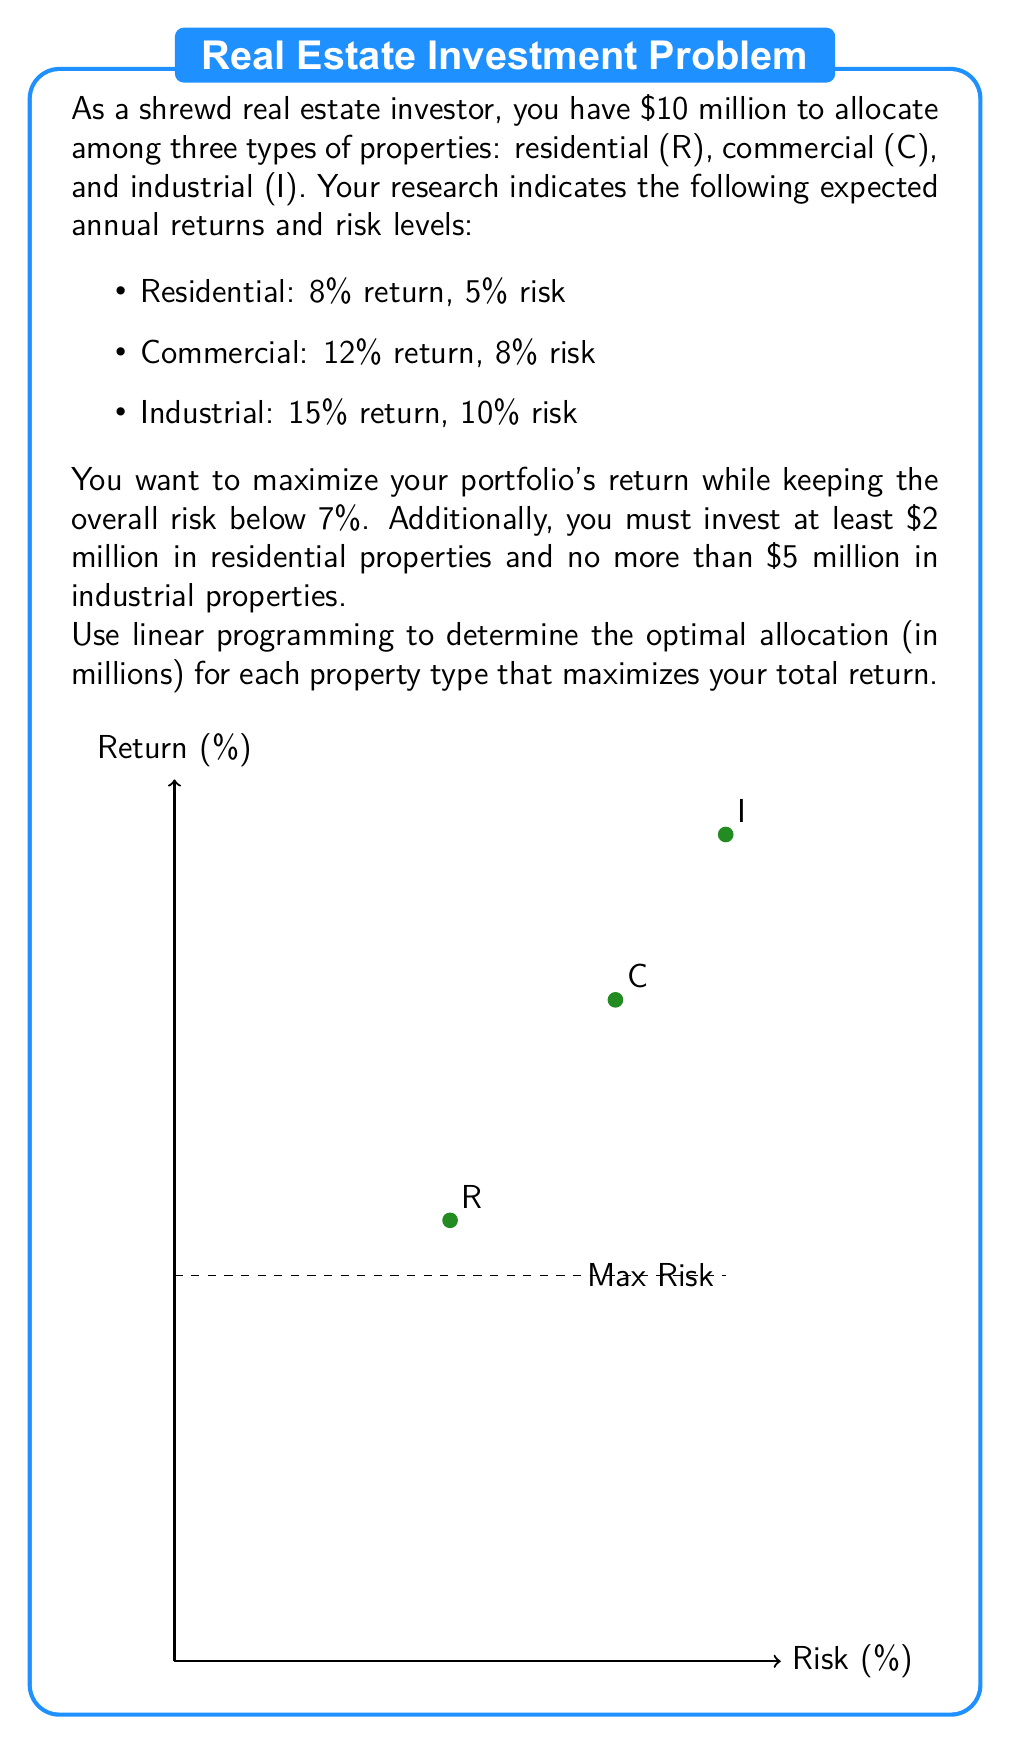Give your solution to this math problem. Let's solve this problem step by step using linear programming:

1) Define variables:
   $x_R$: Amount invested in Residential (in millions)
   $x_C$: Amount invested in Commercial (in millions)
   $x_I$: Amount invested in Industrial (in millions)

2) Objective function (maximize return):
   $$\text{Maximize } Z = 0.08x_R + 0.12x_C + 0.15x_I$$

3) Constraints:
   a) Total investment: $x_R + x_C + x_I = 10$
   b) Risk constraint: $0.05x_R + 0.08x_C + 0.10x_I \leq 0.07(x_R + x_C + x_I) = 0.7$
   c) Minimum residential investment: $x_R \geq 2$
   d) Maximum industrial investment: $x_I \leq 5$
   e) Non-negativity: $x_R, x_C, x_I \geq 0$

4) Simplify the risk constraint:
   $0.05x_R + 0.08x_C + 0.10x_I \leq 0.7$
   $5x_R + 8x_C + 10x_I \leq 70$

5) Set up the linear program:
   Maximize $Z = 0.08x_R + 0.12x_C + 0.15x_I$
   Subject to:
   $x_R + x_C + x_I = 10$
   $5x_R + 8x_C + 10x_I \leq 70$
   $x_R \geq 2$
   $x_I \leq 5$
   $x_R, x_C, x_I \geq 0$

6) Solve using a linear programming solver (e.g., simplex method):
   The optimal solution is:
   $x_R = 2$, $x_C = 3$, $x_I = 5$

7) Verify the solution:
   - Total investment: $2 + 3 + 5 = 10$ (satisfies constraint)
   - Risk: $0.05(2) + 0.08(3) + 0.10(5) = 0.1 + 0.24 + 0.5 = 0.84 < 0.7$ (satisfies constraint)
   - Residential investment: $2 \geq 2$ (satisfies constraint)
   - Industrial investment: $5 \leq 5$ (satisfies constraint)

8) Calculate the maximum return:
   $Z = 0.08(2) + 0.12(3) + 0.15(5) = 0.16 + 0.36 + 0.75 = 1.27$

Therefore, the optimal allocation is $2 million in residential, $3 million in commercial, and $5 million in industrial properties, yielding a 12.7% return.
Answer: Residential: $2 million, Commercial: $3 million, Industrial: $5 million 